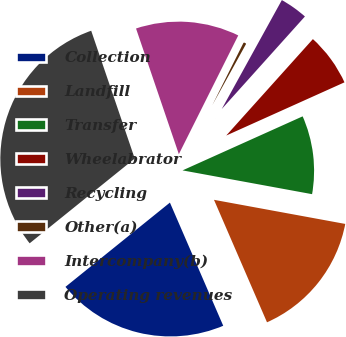Convert chart to OTSL. <chart><loc_0><loc_0><loc_500><loc_500><pie_chart><fcel>Collection<fcel>Landfill<fcel>Transfer<fcel>Wheelabrator<fcel>Recycling<fcel>Other(a)<fcel>Intercompany(b)<fcel>Operating revenues<nl><fcel>20.7%<fcel>15.61%<fcel>9.62%<fcel>6.62%<fcel>3.63%<fcel>0.64%<fcel>12.61%<fcel>30.58%<nl></chart> 